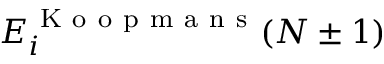Convert formula to latex. <formula><loc_0><loc_0><loc_500><loc_500>E _ { i } ^ { K o o p m a n s } ( N \pm 1 )</formula> 